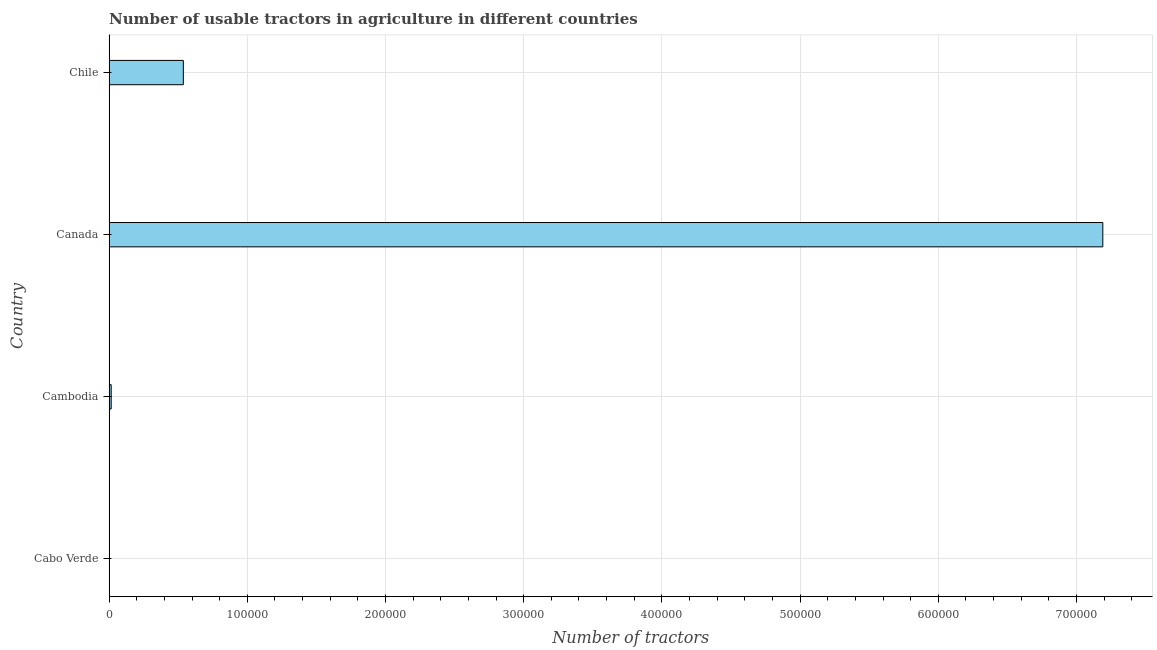Does the graph contain grids?
Your response must be concise. Yes. What is the title of the graph?
Offer a terse response. Number of usable tractors in agriculture in different countries. What is the label or title of the X-axis?
Ensure brevity in your answer.  Number of tractors. What is the label or title of the Y-axis?
Provide a short and direct response. Country. Across all countries, what is the maximum number of tractors?
Keep it short and to the point. 7.19e+05. Across all countries, what is the minimum number of tractors?
Your answer should be very brief. 45. In which country was the number of tractors minimum?
Offer a terse response. Cabo Verde. What is the sum of the number of tractors?
Offer a very short reply. 7.74e+05. What is the difference between the number of tractors in Cabo Verde and Cambodia?
Your answer should be compact. -1495. What is the average number of tractors per country?
Offer a terse response. 1.94e+05. What is the median number of tractors?
Your answer should be compact. 2.76e+04. In how many countries, is the number of tractors greater than 520000 ?
Provide a short and direct response. 1. Is the difference between the number of tractors in Cabo Verde and Cambodia greater than the difference between any two countries?
Offer a very short reply. No. What is the difference between the highest and the second highest number of tractors?
Offer a terse response. 6.65e+05. Is the sum of the number of tractors in Canada and Chile greater than the maximum number of tractors across all countries?
Keep it short and to the point. Yes. What is the difference between the highest and the lowest number of tractors?
Give a very brief answer. 7.19e+05. How many bars are there?
Offer a terse response. 4. What is the difference between two consecutive major ticks on the X-axis?
Make the answer very short. 1.00e+05. What is the Number of tractors of Cambodia?
Your answer should be very brief. 1540. What is the Number of tractors of Canada?
Offer a very short reply. 7.19e+05. What is the Number of tractors of Chile?
Ensure brevity in your answer.  5.37e+04. What is the difference between the Number of tractors in Cabo Verde and Cambodia?
Offer a very short reply. -1495. What is the difference between the Number of tractors in Cabo Verde and Canada?
Provide a short and direct response. -7.19e+05. What is the difference between the Number of tractors in Cabo Verde and Chile?
Give a very brief answer. -5.37e+04. What is the difference between the Number of tractors in Cambodia and Canada?
Make the answer very short. -7.17e+05. What is the difference between the Number of tractors in Cambodia and Chile?
Your response must be concise. -5.22e+04. What is the difference between the Number of tractors in Canada and Chile?
Offer a very short reply. 6.65e+05. What is the ratio of the Number of tractors in Cabo Verde to that in Cambodia?
Your response must be concise. 0.03. What is the ratio of the Number of tractors in Cambodia to that in Canada?
Your answer should be very brief. 0. What is the ratio of the Number of tractors in Cambodia to that in Chile?
Provide a short and direct response. 0.03. What is the ratio of the Number of tractors in Canada to that in Chile?
Keep it short and to the point. 13.38. 